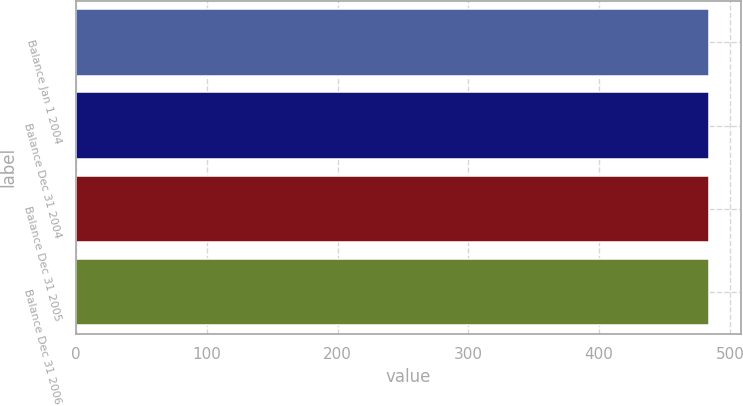Convert chart to OTSL. <chart><loc_0><loc_0><loc_500><loc_500><bar_chart><fcel>Balance Jan 1 2004<fcel>Balance Dec 31 2004<fcel>Balance Dec 31 2005<fcel>Balance Dec 31 2006<nl><fcel>484<fcel>484.1<fcel>484.2<fcel>484.3<nl></chart> 